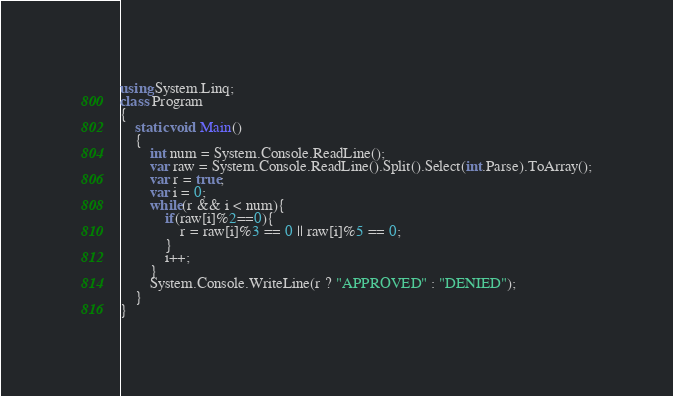Convert code to text. <code><loc_0><loc_0><loc_500><loc_500><_C#_>using System.Linq;
class Program
{
    static void Main()
    {
        int num = System.Console.ReadLine();
        var raw = System.Console.ReadLine().Split().Select(int.Parse).ToArray();
        var r = true;
        var i = 0;
        while(r && i < num){
            if(raw[i]%2==0){
                r = raw[i]%3 == 0 || raw[i]%5 == 0;
            }
            i++;
        }
        System.Console.WriteLine(r ? "APPROVED" : "DENIED");
    }
}
</code> 